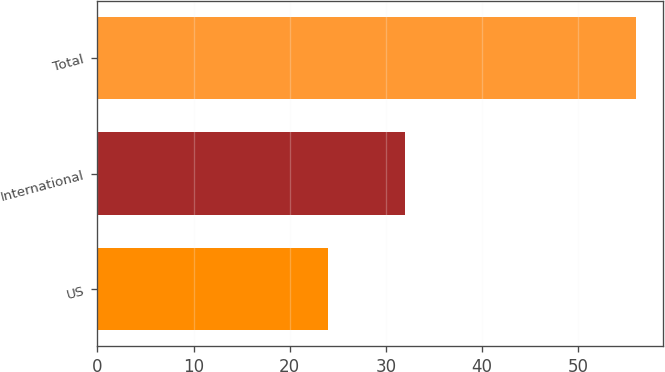Convert chart to OTSL. <chart><loc_0><loc_0><loc_500><loc_500><bar_chart><fcel>US<fcel>International<fcel>Total<nl><fcel>24<fcel>32<fcel>56<nl></chart> 